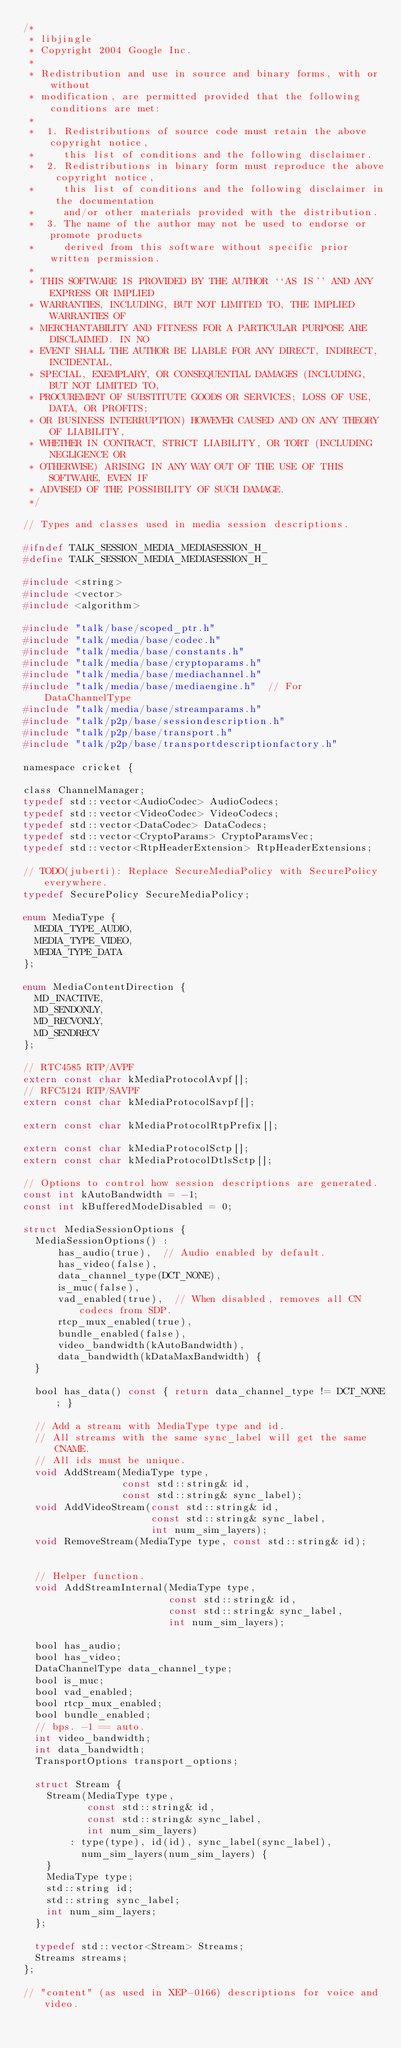Convert code to text. <code><loc_0><loc_0><loc_500><loc_500><_C_>/*
 * libjingle
 * Copyright 2004 Google Inc.
 *
 * Redistribution and use in source and binary forms, with or without
 * modification, are permitted provided that the following conditions are met:
 *
 *  1. Redistributions of source code must retain the above copyright notice,
 *     this list of conditions and the following disclaimer.
 *  2. Redistributions in binary form must reproduce the above copyright notice,
 *     this list of conditions and the following disclaimer in the documentation
 *     and/or other materials provided with the distribution.
 *  3. The name of the author may not be used to endorse or promote products
 *     derived from this software without specific prior written permission.
 *
 * THIS SOFTWARE IS PROVIDED BY THE AUTHOR ``AS IS'' AND ANY EXPRESS OR IMPLIED
 * WARRANTIES, INCLUDING, BUT NOT LIMITED TO, THE IMPLIED WARRANTIES OF
 * MERCHANTABILITY AND FITNESS FOR A PARTICULAR PURPOSE ARE DISCLAIMED. IN NO
 * EVENT SHALL THE AUTHOR BE LIABLE FOR ANY DIRECT, INDIRECT, INCIDENTAL,
 * SPECIAL, EXEMPLARY, OR CONSEQUENTIAL DAMAGES (INCLUDING, BUT NOT LIMITED TO,
 * PROCUREMENT OF SUBSTITUTE GOODS OR SERVICES; LOSS OF USE, DATA, OR PROFITS;
 * OR BUSINESS INTERRUPTION) HOWEVER CAUSED AND ON ANY THEORY OF LIABILITY,
 * WHETHER IN CONTRACT, STRICT LIABILITY, OR TORT (INCLUDING NEGLIGENCE OR
 * OTHERWISE) ARISING IN ANY WAY OUT OF THE USE OF THIS SOFTWARE, EVEN IF
 * ADVISED OF THE POSSIBILITY OF SUCH DAMAGE.
 */

// Types and classes used in media session descriptions.

#ifndef TALK_SESSION_MEDIA_MEDIASESSION_H_
#define TALK_SESSION_MEDIA_MEDIASESSION_H_

#include <string>
#include <vector>
#include <algorithm>

#include "talk/base/scoped_ptr.h"
#include "talk/media/base/codec.h"
#include "talk/media/base/constants.h"
#include "talk/media/base/cryptoparams.h"
#include "talk/media/base/mediachannel.h"
#include "talk/media/base/mediaengine.h"  // For DataChannelType
#include "talk/media/base/streamparams.h"
#include "talk/p2p/base/sessiondescription.h"
#include "talk/p2p/base/transport.h"
#include "talk/p2p/base/transportdescriptionfactory.h"

namespace cricket {

class ChannelManager;
typedef std::vector<AudioCodec> AudioCodecs;
typedef std::vector<VideoCodec> VideoCodecs;
typedef std::vector<DataCodec> DataCodecs;
typedef std::vector<CryptoParams> CryptoParamsVec;
typedef std::vector<RtpHeaderExtension> RtpHeaderExtensions;

// TODO(juberti): Replace SecureMediaPolicy with SecurePolicy everywhere.
typedef SecurePolicy SecureMediaPolicy;

enum MediaType {
  MEDIA_TYPE_AUDIO,
  MEDIA_TYPE_VIDEO,
  MEDIA_TYPE_DATA
};

enum MediaContentDirection {
  MD_INACTIVE,
  MD_SENDONLY,
  MD_RECVONLY,
  MD_SENDRECV
};

// RTC4585 RTP/AVPF
extern const char kMediaProtocolAvpf[];
// RFC5124 RTP/SAVPF
extern const char kMediaProtocolSavpf[];

extern const char kMediaProtocolRtpPrefix[];

extern const char kMediaProtocolSctp[];
extern const char kMediaProtocolDtlsSctp[];

// Options to control how session descriptions are generated.
const int kAutoBandwidth = -1;
const int kBufferedModeDisabled = 0;

struct MediaSessionOptions {
  MediaSessionOptions() :
      has_audio(true),  // Audio enabled by default.
      has_video(false),
      data_channel_type(DCT_NONE),
      is_muc(false),
      vad_enabled(true),  // When disabled, removes all CN codecs from SDP.
      rtcp_mux_enabled(true),
      bundle_enabled(false),
      video_bandwidth(kAutoBandwidth),
      data_bandwidth(kDataMaxBandwidth) {
  }

  bool has_data() const { return data_channel_type != DCT_NONE; }

  // Add a stream with MediaType type and id.
  // All streams with the same sync_label will get the same CNAME.
  // All ids must be unique.
  void AddStream(MediaType type,
                 const std::string& id,
                 const std::string& sync_label);
  void AddVideoStream(const std::string& id,
                      const std::string& sync_label,
                      int num_sim_layers);
  void RemoveStream(MediaType type, const std::string& id);


  // Helper function.
  void AddStreamInternal(MediaType type,
                         const std::string& id,
                         const std::string& sync_label,
                         int num_sim_layers);

  bool has_audio;
  bool has_video;
  DataChannelType data_channel_type;
  bool is_muc;
  bool vad_enabled;
  bool rtcp_mux_enabled;
  bool bundle_enabled;
  // bps. -1 == auto.
  int video_bandwidth;
  int data_bandwidth;
  TransportOptions transport_options;

  struct Stream {
    Stream(MediaType type,
           const std::string& id,
           const std::string& sync_label,
           int num_sim_layers)
        : type(type), id(id), sync_label(sync_label),
          num_sim_layers(num_sim_layers) {
    }
    MediaType type;
    std::string id;
    std::string sync_label;
    int num_sim_layers;
  };

  typedef std::vector<Stream> Streams;
  Streams streams;
};

// "content" (as used in XEP-0166) descriptions for voice and video.</code> 